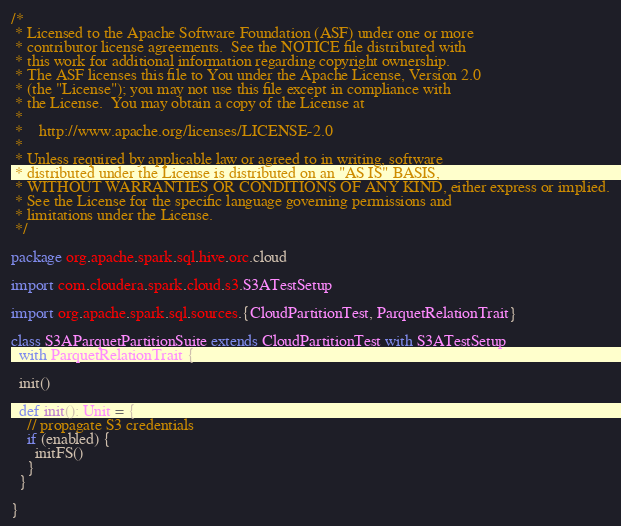<code> <loc_0><loc_0><loc_500><loc_500><_Scala_>/*
 * Licensed to the Apache Software Foundation (ASF) under one or more
 * contributor license agreements.  See the NOTICE file distributed with
 * this work for additional information regarding copyright ownership.
 * The ASF licenses this file to You under the Apache License, Version 2.0
 * (the "License"); you may not use this file except in compliance with
 * the License.  You may obtain a copy of the License at
 *
 *    http://www.apache.org/licenses/LICENSE-2.0
 *
 * Unless required by applicable law or agreed to in writing, software
 * distributed under the License is distributed on an "AS IS" BASIS,
 * WITHOUT WARRANTIES OR CONDITIONS OF ANY KIND, either express or implied.
 * See the License for the specific language governing permissions and
 * limitations under the License.
 */

package org.apache.spark.sql.hive.orc.cloud

import com.cloudera.spark.cloud.s3.S3ATestSetup

import org.apache.spark.sql.sources.{CloudPartitionTest, ParquetRelationTrait}

class S3AParquetPartitionSuite extends CloudPartitionTest with S3ATestSetup
  with ParquetRelationTrait {

  init()

  def init(): Unit = {
    // propagate S3 credentials
    if (enabled) {
      initFS()
    }
  }

}
</code> 